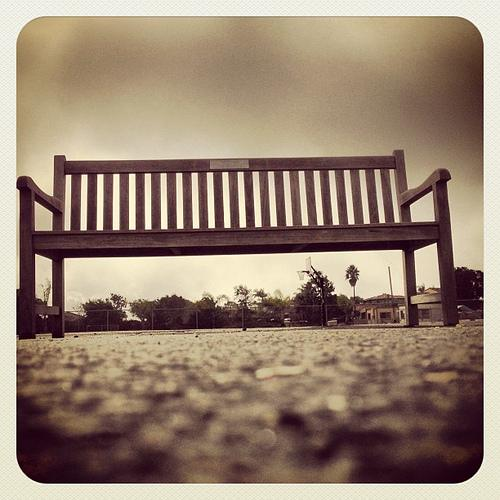Describe the composition of the image with respect to the bench, fence, trees, and other elements. The image features a brown wooden bench on gravel and dirt ground in a park, with a metal fence running behind it, tall trees in the distance, a basketball hoop to its right, and houses in the background. The photo is taken in black and white, and it is a cloudy day. Is the image taken during a sunny or cloudy day? The image is taken during a cloudy day. Briefly describe the weather in the image. The weather appears to be overcast, with a dark and cloudy sky. Is there anything unusual about the coloring of the photograph? If yes, describe it. Yes, the photo appears to be taken in black and white. In relation to the bench, where is the basketball hoop located? The basketball hoop is in the park, located behind and to the right of the bench. What type of fence is in the image, and where is it located in relation to the other subjects? There is a metal fence in the image, located behind the bench and between the trees and the basketball court. What is the primary object in the picture and its color? The primary object is a bench, and it is brown. Can you identify any notable features in the background of the image? There are houses, trees, and a basketball court in the background of the image. Mention any special features or characteristics of the bench in the image. The bench is made of wood, has slats on the back, and has a label or metal plate on the back. What type of ground surface is the bench situated on? The bench is situated on a ground surface consisting of gravel and dirt. 